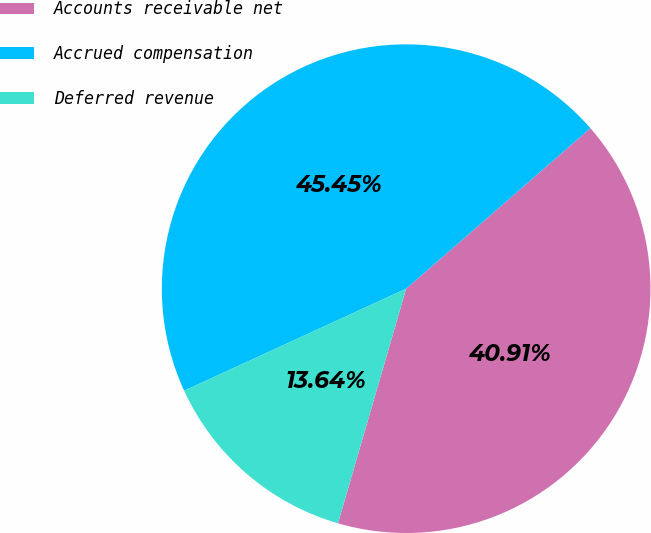<chart> <loc_0><loc_0><loc_500><loc_500><pie_chart><fcel>Accounts receivable net<fcel>Accrued compensation<fcel>Deferred revenue<nl><fcel>40.91%<fcel>45.45%<fcel>13.64%<nl></chart> 